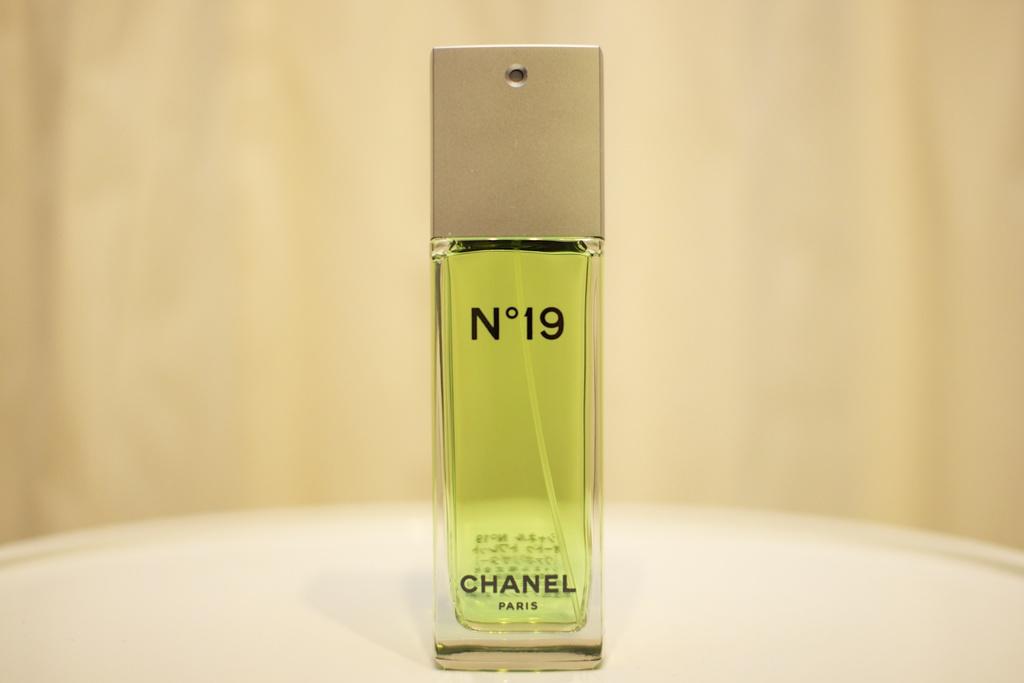What brand name is the perfume ?
Provide a succinct answer. Chanel. What number is this perfume?
Provide a succinct answer. 19. 